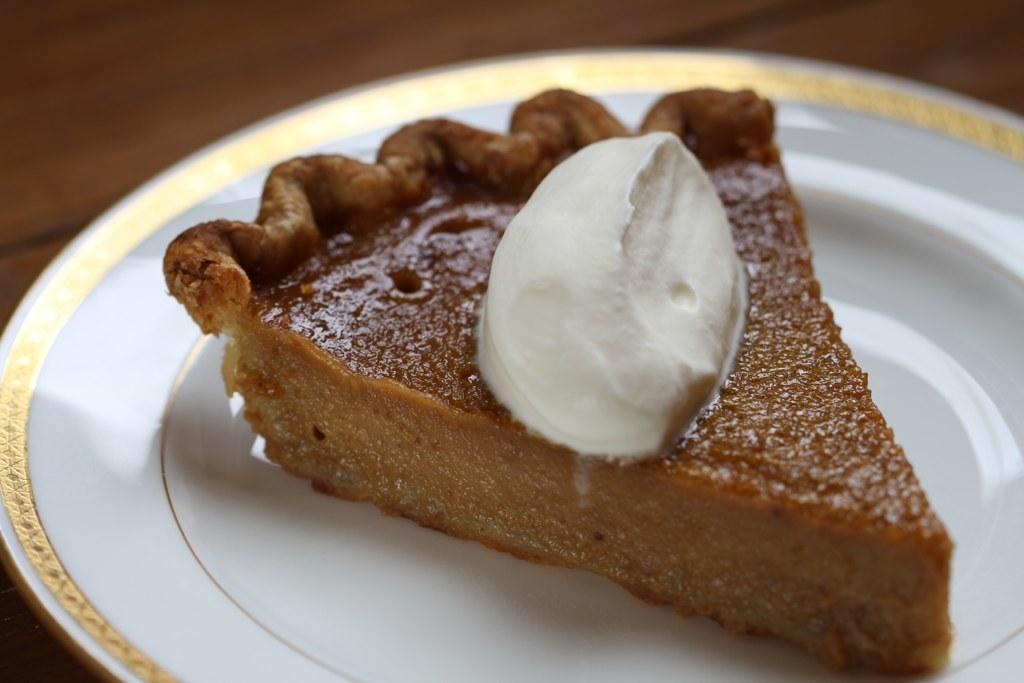How would you summarize this image in a sentence or two? In this picture, we see a white plate containing a pumpkin pie. This plate might be placed on a table. In the background, it is brown in color. This picture is blurred in the background. 